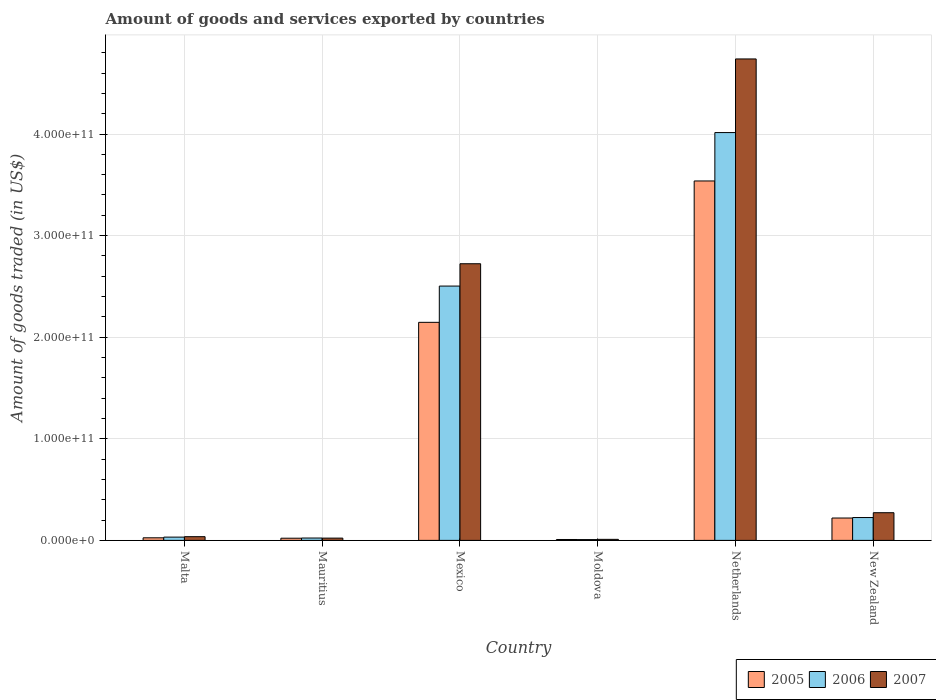Are the number of bars per tick equal to the number of legend labels?
Your response must be concise. Yes. How many bars are there on the 2nd tick from the left?
Your answer should be compact. 3. What is the label of the 2nd group of bars from the left?
Your answer should be compact. Mauritius. What is the total amount of goods and services exported in 2005 in Malta?
Provide a short and direct response. 2.54e+09. Across all countries, what is the maximum total amount of goods and services exported in 2005?
Offer a terse response. 3.54e+11. Across all countries, what is the minimum total amount of goods and services exported in 2005?
Ensure brevity in your answer.  8.86e+08. In which country was the total amount of goods and services exported in 2007 maximum?
Your response must be concise. Netherlands. In which country was the total amount of goods and services exported in 2005 minimum?
Keep it short and to the point. Moldova. What is the total total amount of goods and services exported in 2007 in the graph?
Give a very brief answer. 7.80e+11. What is the difference between the total amount of goods and services exported in 2007 in Mexico and that in Moldova?
Offer a terse response. 2.71e+11. What is the difference between the total amount of goods and services exported in 2007 in Malta and the total amount of goods and services exported in 2006 in New Zealand?
Offer a very short reply. -1.88e+1. What is the average total amount of goods and services exported in 2006 per country?
Keep it short and to the point. 1.13e+11. What is the difference between the total amount of goods and services exported of/in 2006 and total amount of goods and services exported of/in 2007 in Netherlands?
Make the answer very short. -7.25e+1. In how many countries, is the total amount of goods and services exported in 2007 greater than 160000000000 US$?
Provide a short and direct response. 2. What is the ratio of the total amount of goods and services exported in 2005 in Malta to that in Mauritius?
Offer a very short reply. 1.19. Is the total amount of goods and services exported in 2005 in Malta less than that in New Zealand?
Provide a succinct answer. Yes. Is the difference between the total amount of goods and services exported in 2006 in Netherlands and New Zealand greater than the difference between the total amount of goods and services exported in 2007 in Netherlands and New Zealand?
Keep it short and to the point. No. What is the difference between the highest and the second highest total amount of goods and services exported in 2007?
Your answer should be compact. 2.02e+11. What is the difference between the highest and the lowest total amount of goods and services exported in 2007?
Provide a short and direct response. 4.73e+11. In how many countries, is the total amount of goods and services exported in 2006 greater than the average total amount of goods and services exported in 2006 taken over all countries?
Provide a succinct answer. 2. What does the 3rd bar from the left in Netherlands represents?
Give a very brief answer. 2007. What does the 1st bar from the right in Netherlands represents?
Provide a short and direct response. 2007. How many bars are there?
Give a very brief answer. 18. What is the difference between two consecutive major ticks on the Y-axis?
Your answer should be very brief. 1.00e+11. Does the graph contain grids?
Provide a short and direct response. Yes. How many legend labels are there?
Provide a short and direct response. 3. How are the legend labels stacked?
Your response must be concise. Horizontal. What is the title of the graph?
Your answer should be very brief. Amount of goods and services exported by countries. Does "2014" appear as one of the legend labels in the graph?
Keep it short and to the point. No. What is the label or title of the Y-axis?
Provide a succinct answer. Amount of goods traded (in US$). What is the Amount of goods traded (in US$) of 2005 in Malta?
Ensure brevity in your answer.  2.54e+09. What is the Amount of goods traded (in US$) of 2006 in Malta?
Make the answer very short. 3.23e+09. What is the Amount of goods traded (in US$) in 2007 in Malta?
Your answer should be very brief. 3.66e+09. What is the Amount of goods traded (in US$) in 2005 in Mauritius?
Give a very brief answer. 2.14e+09. What is the Amount of goods traded (in US$) of 2006 in Mauritius?
Ensure brevity in your answer.  2.33e+09. What is the Amount of goods traded (in US$) in 2007 in Mauritius?
Ensure brevity in your answer.  2.24e+09. What is the Amount of goods traded (in US$) of 2005 in Mexico?
Your answer should be compact. 2.15e+11. What is the Amount of goods traded (in US$) in 2006 in Mexico?
Offer a very short reply. 2.50e+11. What is the Amount of goods traded (in US$) in 2007 in Mexico?
Offer a terse response. 2.72e+11. What is the Amount of goods traded (in US$) in 2005 in Moldova?
Give a very brief answer. 8.86e+08. What is the Amount of goods traded (in US$) of 2006 in Moldova?
Make the answer very short. 7.87e+08. What is the Amount of goods traded (in US$) of 2007 in Moldova?
Your answer should be very brief. 1.03e+09. What is the Amount of goods traded (in US$) of 2005 in Netherlands?
Ensure brevity in your answer.  3.54e+11. What is the Amount of goods traded (in US$) of 2006 in Netherlands?
Offer a very short reply. 4.01e+11. What is the Amount of goods traded (in US$) in 2007 in Netherlands?
Your answer should be compact. 4.74e+11. What is the Amount of goods traded (in US$) in 2005 in New Zealand?
Your response must be concise. 2.20e+1. What is the Amount of goods traded (in US$) in 2006 in New Zealand?
Provide a succinct answer. 2.25e+1. What is the Amount of goods traded (in US$) in 2007 in New Zealand?
Provide a short and direct response. 2.72e+1. Across all countries, what is the maximum Amount of goods traded (in US$) of 2005?
Ensure brevity in your answer.  3.54e+11. Across all countries, what is the maximum Amount of goods traded (in US$) of 2006?
Offer a very short reply. 4.01e+11. Across all countries, what is the maximum Amount of goods traded (in US$) of 2007?
Your answer should be very brief. 4.74e+11. Across all countries, what is the minimum Amount of goods traded (in US$) in 2005?
Your answer should be very brief. 8.86e+08. Across all countries, what is the minimum Amount of goods traded (in US$) of 2006?
Offer a very short reply. 7.87e+08. Across all countries, what is the minimum Amount of goods traded (in US$) of 2007?
Ensure brevity in your answer.  1.03e+09. What is the total Amount of goods traded (in US$) in 2005 in the graph?
Your response must be concise. 5.96e+11. What is the total Amount of goods traded (in US$) in 2006 in the graph?
Your answer should be very brief. 6.81e+11. What is the total Amount of goods traded (in US$) in 2007 in the graph?
Ensure brevity in your answer.  7.80e+11. What is the difference between the Amount of goods traded (in US$) in 2005 in Malta and that in Mauritius?
Provide a short and direct response. 4.06e+08. What is the difference between the Amount of goods traded (in US$) in 2006 in Malta and that in Mauritius?
Keep it short and to the point. 8.99e+08. What is the difference between the Amount of goods traded (in US$) in 2007 in Malta and that in Mauritius?
Give a very brief answer. 1.42e+09. What is the difference between the Amount of goods traded (in US$) in 2005 in Malta and that in Mexico?
Give a very brief answer. -2.12e+11. What is the difference between the Amount of goods traded (in US$) of 2006 in Malta and that in Mexico?
Your response must be concise. -2.47e+11. What is the difference between the Amount of goods traded (in US$) of 2007 in Malta and that in Mexico?
Make the answer very short. -2.69e+11. What is the difference between the Amount of goods traded (in US$) of 2005 in Malta and that in Moldova?
Offer a very short reply. 1.66e+09. What is the difference between the Amount of goods traded (in US$) in 2006 in Malta and that in Moldova?
Your answer should be very brief. 2.44e+09. What is the difference between the Amount of goods traded (in US$) of 2007 in Malta and that in Moldova?
Ensure brevity in your answer.  2.63e+09. What is the difference between the Amount of goods traded (in US$) in 2005 in Malta and that in Netherlands?
Your answer should be compact. -3.51e+11. What is the difference between the Amount of goods traded (in US$) in 2006 in Malta and that in Netherlands?
Your response must be concise. -3.98e+11. What is the difference between the Amount of goods traded (in US$) of 2007 in Malta and that in Netherlands?
Offer a terse response. -4.70e+11. What is the difference between the Amount of goods traded (in US$) in 2005 in Malta and that in New Zealand?
Your answer should be compact. -1.95e+1. What is the difference between the Amount of goods traded (in US$) in 2006 in Malta and that in New Zealand?
Give a very brief answer. -1.93e+1. What is the difference between the Amount of goods traded (in US$) in 2007 in Malta and that in New Zealand?
Give a very brief answer. -2.36e+1. What is the difference between the Amount of goods traded (in US$) in 2005 in Mauritius and that in Mexico?
Make the answer very short. -2.12e+11. What is the difference between the Amount of goods traded (in US$) in 2006 in Mauritius and that in Mexico?
Your answer should be compact. -2.48e+11. What is the difference between the Amount of goods traded (in US$) in 2007 in Mauritius and that in Mexico?
Your answer should be very brief. -2.70e+11. What is the difference between the Amount of goods traded (in US$) in 2005 in Mauritius and that in Moldova?
Provide a succinct answer. 1.25e+09. What is the difference between the Amount of goods traded (in US$) in 2006 in Mauritius and that in Moldova?
Ensure brevity in your answer.  1.54e+09. What is the difference between the Amount of goods traded (in US$) of 2007 in Mauritius and that in Moldova?
Give a very brief answer. 1.21e+09. What is the difference between the Amount of goods traded (in US$) in 2005 in Mauritius and that in Netherlands?
Make the answer very short. -3.52e+11. What is the difference between the Amount of goods traded (in US$) in 2006 in Mauritius and that in Netherlands?
Keep it short and to the point. -3.99e+11. What is the difference between the Amount of goods traded (in US$) of 2007 in Mauritius and that in Netherlands?
Offer a very short reply. -4.72e+11. What is the difference between the Amount of goods traded (in US$) of 2005 in Mauritius and that in New Zealand?
Provide a short and direct response. -1.99e+1. What is the difference between the Amount of goods traded (in US$) of 2006 in Mauritius and that in New Zealand?
Provide a short and direct response. -2.02e+1. What is the difference between the Amount of goods traded (in US$) of 2007 in Mauritius and that in New Zealand?
Your response must be concise. -2.50e+1. What is the difference between the Amount of goods traded (in US$) in 2005 in Mexico and that in Moldova?
Provide a succinct answer. 2.14e+11. What is the difference between the Amount of goods traded (in US$) in 2006 in Mexico and that in Moldova?
Your answer should be compact. 2.50e+11. What is the difference between the Amount of goods traded (in US$) in 2007 in Mexico and that in Moldova?
Give a very brief answer. 2.71e+11. What is the difference between the Amount of goods traded (in US$) of 2005 in Mexico and that in Netherlands?
Offer a very short reply. -1.39e+11. What is the difference between the Amount of goods traded (in US$) in 2006 in Mexico and that in Netherlands?
Give a very brief answer. -1.51e+11. What is the difference between the Amount of goods traded (in US$) of 2007 in Mexico and that in Netherlands?
Provide a short and direct response. -2.02e+11. What is the difference between the Amount of goods traded (in US$) of 2005 in Mexico and that in New Zealand?
Your answer should be very brief. 1.93e+11. What is the difference between the Amount of goods traded (in US$) in 2006 in Mexico and that in New Zealand?
Provide a succinct answer. 2.28e+11. What is the difference between the Amount of goods traded (in US$) in 2007 in Mexico and that in New Zealand?
Offer a very short reply. 2.45e+11. What is the difference between the Amount of goods traded (in US$) in 2005 in Moldova and that in Netherlands?
Keep it short and to the point. -3.53e+11. What is the difference between the Amount of goods traded (in US$) in 2006 in Moldova and that in Netherlands?
Your answer should be compact. -4.01e+11. What is the difference between the Amount of goods traded (in US$) in 2007 in Moldova and that in Netherlands?
Your response must be concise. -4.73e+11. What is the difference between the Amount of goods traded (in US$) of 2005 in Moldova and that in New Zealand?
Ensure brevity in your answer.  -2.11e+1. What is the difference between the Amount of goods traded (in US$) of 2006 in Moldova and that in New Zealand?
Ensure brevity in your answer.  -2.17e+1. What is the difference between the Amount of goods traded (in US$) in 2007 in Moldova and that in New Zealand?
Offer a terse response. -2.62e+1. What is the difference between the Amount of goods traded (in US$) in 2005 in Netherlands and that in New Zealand?
Keep it short and to the point. 3.32e+11. What is the difference between the Amount of goods traded (in US$) in 2006 in Netherlands and that in New Zealand?
Your response must be concise. 3.79e+11. What is the difference between the Amount of goods traded (in US$) of 2007 in Netherlands and that in New Zealand?
Offer a terse response. 4.47e+11. What is the difference between the Amount of goods traded (in US$) in 2005 in Malta and the Amount of goods traded (in US$) in 2006 in Mauritius?
Your answer should be very brief. 2.16e+08. What is the difference between the Amount of goods traded (in US$) of 2005 in Malta and the Amount of goods traded (in US$) of 2007 in Mauritius?
Your response must be concise. 3.07e+08. What is the difference between the Amount of goods traded (in US$) of 2006 in Malta and the Amount of goods traded (in US$) of 2007 in Mauritius?
Offer a terse response. 9.90e+08. What is the difference between the Amount of goods traded (in US$) in 2005 in Malta and the Amount of goods traded (in US$) in 2006 in Mexico?
Ensure brevity in your answer.  -2.48e+11. What is the difference between the Amount of goods traded (in US$) in 2005 in Malta and the Amount of goods traded (in US$) in 2007 in Mexico?
Make the answer very short. -2.70e+11. What is the difference between the Amount of goods traded (in US$) in 2006 in Malta and the Amount of goods traded (in US$) in 2007 in Mexico?
Offer a very short reply. -2.69e+11. What is the difference between the Amount of goods traded (in US$) in 2005 in Malta and the Amount of goods traded (in US$) in 2006 in Moldova?
Offer a very short reply. 1.76e+09. What is the difference between the Amount of goods traded (in US$) in 2005 in Malta and the Amount of goods traded (in US$) in 2007 in Moldova?
Ensure brevity in your answer.  1.52e+09. What is the difference between the Amount of goods traded (in US$) in 2006 in Malta and the Amount of goods traded (in US$) in 2007 in Moldova?
Your answer should be very brief. 2.20e+09. What is the difference between the Amount of goods traded (in US$) in 2005 in Malta and the Amount of goods traded (in US$) in 2006 in Netherlands?
Your response must be concise. -3.99e+11. What is the difference between the Amount of goods traded (in US$) in 2005 in Malta and the Amount of goods traded (in US$) in 2007 in Netherlands?
Keep it short and to the point. -4.71e+11. What is the difference between the Amount of goods traded (in US$) in 2006 in Malta and the Amount of goods traded (in US$) in 2007 in Netherlands?
Provide a short and direct response. -4.71e+11. What is the difference between the Amount of goods traded (in US$) of 2005 in Malta and the Amount of goods traded (in US$) of 2006 in New Zealand?
Keep it short and to the point. -2.00e+1. What is the difference between the Amount of goods traded (in US$) of 2005 in Malta and the Amount of goods traded (in US$) of 2007 in New Zealand?
Make the answer very short. -2.47e+1. What is the difference between the Amount of goods traded (in US$) of 2006 in Malta and the Amount of goods traded (in US$) of 2007 in New Zealand?
Ensure brevity in your answer.  -2.40e+1. What is the difference between the Amount of goods traded (in US$) in 2005 in Mauritius and the Amount of goods traded (in US$) in 2006 in Mexico?
Make the answer very short. -2.48e+11. What is the difference between the Amount of goods traded (in US$) in 2005 in Mauritius and the Amount of goods traded (in US$) in 2007 in Mexico?
Offer a very short reply. -2.70e+11. What is the difference between the Amount of goods traded (in US$) of 2006 in Mauritius and the Amount of goods traded (in US$) of 2007 in Mexico?
Keep it short and to the point. -2.70e+11. What is the difference between the Amount of goods traded (in US$) of 2005 in Mauritius and the Amount of goods traded (in US$) of 2006 in Moldova?
Offer a terse response. 1.35e+09. What is the difference between the Amount of goods traded (in US$) of 2005 in Mauritius and the Amount of goods traded (in US$) of 2007 in Moldova?
Your answer should be compact. 1.11e+09. What is the difference between the Amount of goods traded (in US$) in 2006 in Mauritius and the Amount of goods traded (in US$) in 2007 in Moldova?
Offer a very short reply. 1.30e+09. What is the difference between the Amount of goods traded (in US$) of 2005 in Mauritius and the Amount of goods traded (in US$) of 2006 in Netherlands?
Your answer should be very brief. -3.99e+11. What is the difference between the Amount of goods traded (in US$) in 2005 in Mauritius and the Amount of goods traded (in US$) in 2007 in Netherlands?
Make the answer very short. -4.72e+11. What is the difference between the Amount of goods traded (in US$) in 2006 in Mauritius and the Amount of goods traded (in US$) in 2007 in Netherlands?
Make the answer very short. -4.72e+11. What is the difference between the Amount of goods traded (in US$) in 2005 in Mauritius and the Amount of goods traded (in US$) in 2006 in New Zealand?
Your response must be concise. -2.04e+1. What is the difference between the Amount of goods traded (in US$) in 2005 in Mauritius and the Amount of goods traded (in US$) in 2007 in New Zealand?
Make the answer very short. -2.51e+1. What is the difference between the Amount of goods traded (in US$) in 2006 in Mauritius and the Amount of goods traded (in US$) in 2007 in New Zealand?
Offer a terse response. -2.49e+1. What is the difference between the Amount of goods traded (in US$) of 2005 in Mexico and the Amount of goods traded (in US$) of 2006 in Moldova?
Your answer should be very brief. 2.14e+11. What is the difference between the Amount of goods traded (in US$) of 2005 in Mexico and the Amount of goods traded (in US$) of 2007 in Moldova?
Your answer should be compact. 2.14e+11. What is the difference between the Amount of goods traded (in US$) in 2006 in Mexico and the Amount of goods traded (in US$) in 2007 in Moldova?
Offer a terse response. 2.49e+11. What is the difference between the Amount of goods traded (in US$) of 2005 in Mexico and the Amount of goods traded (in US$) of 2006 in Netherlands?
Provide a short and direct response. -1.87e+11. What is the difference between the Amount of goods traded (in US$) in 2005 in Mexico and the Amount of goods traded (in US$) in 2007 in Netherlands?
Provide a succinct answer. -2.59e+11. What is the difference between the Amount of goods traded (in US$) of 2006 in Mexico and the Amount of goods traded (in US$) of 2007 in Netherlands?
Your answer should be compact. -2.24e+11. What is the difference between the Amount of goods traded (in US$) in 2005 in Mexico and the Amount of goods traded (in US$) in 2006 in New Zealand?
Offer a terse response. 1.92e+11. What is the difference between the Amount of goods traded (in US$) in 2005 in Mexico and the Amount of goods traded (in US$) in 2007 in New Zealand?
Ensure brevity in your answer.  1.87e+11. What is the difference between the Amount of goods traded (in US$) in 2006 in Mexico and the Amount of goods traded (in US$) in 2007 in New Zealand?
Your answer should be very brief. 2.23e+11. What is the difference between the Amount of goods traded (in US$) in 2005 in Moldova and the Amount of goods traded (in US$) in 2006 in Netherlands?
Make the answer very short. -4.01e+11. What is the difference between the Amount of goods traded (in US$) in 2005 in Moldova and the Amount of goods traded (in US$) in 2007 in Netherlands?
Keep it short and to the point. -4.73e+11. What is the difference between the Amount of goods traded (in US$) in 2006 in Moldova and the Amount of goods traded (in US$) in 2007 in Netherlands?
Offer a very short reply. -4.73e+11. What is the difference between the Amount of goods traded (in US$) in 2005 in Moldova and the Amount of goods traded (in US$) in 2006 in New Zealand?
Your response must be concise. -2.16e+1. What is the difference between the Amount of goods traded (in US$) in 2005 in Moldova and the Amount of goods traded (in US$) in 2007 in New Zealand?
Give a very brief answer. -2.64e+1. What is the difference between the Amount of goods traded (in US$) of 2006 in Moldova and the Amount of goods traded (in US$) of 2007 in New Zealand?
Give a very brief answer. -2.65e+1. What is the difference between the Amount of goods traded (in US$) of 2005 in Netherlands and the Amount of goods traded (in US$) of 2006 in New Zealand?
Offer a terse response. 3.31e+11. What is the difference between the Amount of goods traded (in US$) of 2005 in Netherlands and the Amount of goods traded (in US$) of 2007 in New Zealand?
Your answer should be compact. 3.27e+11. What is the difference between the Amount of goods traded (in US$) of 2006 in Netherlands and the Amount of goods traded (in US$) of 2007 in New Zealand?
Your answer should be very brief. 3.74e+11. What is the average Amount of goods traded (in US$) of 2005 per country?
Your answer should be very brief. 9.93e+1. What is the average Amount of goods traded (in US$) in 2006 per country?
Provide a succinct answer. 1.13e+11. What is the average Amount of goods traded (in US$) in 2007 per country?
Give a very brief answer. 1.30e+11. What is the difference between the Amount of goods traded (in US$) in 2005 and Amount of goods traded (in US$) in 2006 in Malta?
Your answer should be very brief. -6.83e+08. What is the difference between the Amount of goods traded (in US$) in 2005 and Amount of goods traded (in US$) in 2007 in Malta?
Provide a succinct answer. -1.11e+09. What is the difference between the Amount of goods traded (in US$) of 2006 and Amount of goods traded (in US$) of 2007 in Malta?
Make the answer very short. -4.30e+08. What is the difference between the Amount of goods traded (in US$) of 2005 and Amount of goods traded (in US$) of 2006 in Mauritius?
Provide a short and direct response. -1.90e+08. What is the difference between the Amount of goods traded (in US$) of 2005 and Amount of goods traded (in US$) of 2007 in Mauritius?
Offer a terse response. -9.95e+07. What is the difference between the Amount of goods traded (in US$) in 2006 and Amount of goods traded (in US$) in 2007 in Mauritius?
Your answer should be compact. 9.09e+07. What is the difference between the Amount of goods traded (in US$) in 2005 and Amount of goods traded (in US$) in 2006 in Mexico?
Provide a short and direct response. -3.57e+1. What is the difference between the Amount of goods traded (in US$) of 2005 and Amount of goods traded (in US$) of 2007 in Mexico?
Provide a succinct answer. -5.77e+1. What is the difference between the Amount of goods traded (in US$) of 2006 and Amount of goods traded (in US$) of 2007 in Mexico?
Offer a very short reply. -2.20e+1. What is the difference between the Amount of goods traded (in US$) in 2005 and Amount of goods traded (in US$) in 2006 in Moldova?
Offer a very short reply. 9.92e+07. What is the difference between the Amount of goods traded (in US$) in 2005 and Amount of goods traded (in US$) in 2007 in Moldova?
Make the answer very short. -1.40e+08. What is the difference between the Amount of goods traded (in US$) of 2006 and Amount of goods traded (in US$) of 2007 in Moldova?
Make the answer very short. -2.39e+08. What is the difference between the Amount of goods traded (in US$) of 2005 and Amount of goods traded (in US$) of 2006 in Netherlands?
Offer a very short reply. -4.76e+1. What is the difference between the Amount of goods traded (in US$) in 2005 and Amount of goods traded (in US$) in 2007 in Netherlands?
Keep it short and to the point. -1.20e+11. What is the difference between the Amount of goods traded (in US$) in 2006 and Amount of goods traded (in US$) in 2007 in Netherlands?
Ensure brevity in your answer.  -7.25e+1. What is the difference between the Amount of goods traded (in US$) in 2005 and Amount of goods traded (in US$) in 2006 in New Zealand?
Your answer should be very brief. -4.80e+08. What is the difference between the Amount of goods traded (in US$) of 2005 and Amount of goods traded (in US$) of 2007 in New Zealand?
Offer a terse response. -5.23e+09. What is the difference between the Amount of goods traded (in US$) of 2006 and Amount of goods traded (in US$) of 2007 in New Zealand?
Provide a succinct answer. -4.75e+09. What is the ratio of the Amount of goods traded (in US$) in 2005 in Malta to that in Mauritius?
Provide a succinct answer. 1.19. What is the ratio of the Amount of goods traded (in US$) of 2006 in Malta to that in Mauritius?
Your answer should be compact. 1.39. What is the ratio of the Amount of goods traded (in US$) in 2007 in Malta to that in Mauritius?
Offer a very short reply. 1.63. What is the ratio of the Amount of goods traded (in US$) of 2005 in Malta to that in Mexico?
Offer a very short reply. 0.01. What is the ratio of the Amount of goods traded (in US$) of 2006 in Malta to that in Mexico?
Provide a succinct answer. 0.01. What is the ratio of the Amount of goods traded (in US$) of 2007 in Malta to that in Mexico?
Ensure brevity in your answer.  0.01. What is the ratio of the Amount of goods traded (in US$) in 2005 in Malta to that in Moldova?
Provide a short and direct response. 2.87. What is the ratio of the Amount of goods traded (in US$) in 2006 in Malta to that in Moldova?
Provide a succinct answer. 4.1. What is the ratio of the Amount of goods traded (in US$) of 2007 in Malta to that in Moldova?
Offer a terse response. 3.56. What is the ratio of the Amount of goods traded (in US$) in 2005 in Malta to that in Netherlands?
Your answer should be very brief. 0.01. What is the ratio of the Amount of goods traded (in US$) in 2006 in Malta to that in Netherlands?
Make the answer very short. 0.01. What is the ratio of the Amount of goods traded (in US$) in 2007 in Malta to that in Netherlands?
Offer a very short reply. 0.01. What is the ratio of the Amount of goods traded (in US$) in 2005 in Malta to that in New Zealand?
Ensure brevity in your answer.  0.12. What is the ratio of the Amount of goods traded (in US$) in 2006 in Malta to that in New Zealand?
Offer a very short reply. 0.14. What is the ratio of the Amount of goods traded (in US$) of 2007 in Malta to that in New Zealand?
Make the answer very short. 0.13. What is the ratio of the Amount of goods traded (in US$) of 2006 in Mauritius to that in Mexico?
Provide a short and direct response. 0.01. What is the ratio of the Amount of goods traded (in US$) in 2007 in Mauritius to that in Mexico?
Your response must be concise. 0.01. What is the ratio of the Amount of goods traded (in US$) of 2005 in Mauritius to that in Moldova?
Your answer should be compact. 2.41. What is the ratio of the Amount of goods traded (in US$) of 2006 in Mauritius to that in Moldova?
Keep it short and to the point. 2.96. What is the ratio of the Amount of goods traded (in US$) of 2007 in Mauritius to that in Moldova?
Give a very brief answer. 2.18. What is the ratio of the Amount of goods traded (in US$) of 2005 in Mauritius to that in Netherlands?
Provide a short and direct response. 0.01. What is the ratio of the Amount of goods traded (in US$) of 2006 in Mauritius to that in Netherlands?
Ensure brevity in your answer.  0.01. What is the ratio of the Amount of goods traded (in US$) of 2007 in Mauritius to that in Netherlands?
Your answer should be very brief. 0. What is the ratio of the Amount of goods traded (in US$) in 2005 in Mauritius to that in New Zealand?
Your answer should be compact. 0.1. What is the ratio of the Amount of goods traded (in US$) in 2006 in Mauritius to that in New Zealand?
Your answer should be compact. 0.1. What is the ratio of the Amount of goods traded (in US$) of 2007 in Mauritius to that in New Zealand?
Make the answer very short. 0.08. What is the ratio of the Amount of goods traded (in US$) of 2005 in Mexico to that in Moldova?
Your response must be concise. 242.22. What is the ratio of the Amount of goods traded (in US$) of 2006 in Mexico to that in Moldova?
Keep it short and to the point. 318.09. What is the ratio of the Amount of goods traded (in US$) of 2007 in Mexico to that in Moldova?
Provide a succinct answer. 265.39. What is the ratio of the Amount of goods traded (in US$) of 2005 in Mexico to that in Netherlands?
Your response must be concise. 0.61. What is the ratio of the Amount of goods traded (in US$) of 2006 in Mexico to that in Netherlands?
Provide a short and direct response. 0.62. What is the ratio of the Amount of goods traded (in US$) of 2007 in Mexico to that in Netherlands?
Your answer should be compact. 0.57. What is the ratio of the Amount of goods traded (in US$) of 2005 in Mexico to that in New Zealand?
Offer a terse response. 9.75. What is the ratio of the Amount of goods traded (in US$) in 2006 in Mexico to that in New Zealand?
Your response must be concise. 11.13. What is the ratio of the Amount of goods traded (in US$) in 2007 in Mexico to that in New Zealand?
Keep it short and to the point. 10. What is the ratio of the Amount of goods traded (in US$) in 2005 in Moldova to that in Netherlands?
Provide a short and direct response. 0. What is the ratio of the Amount of goods traded (in US$) in 2006 in Moldova to that in Netherlands?
Your answer should be very brief. 0. What is the ratio of the Amount of goods traded (in US$) in 2007 in Moldova to that in Netherlands?
Keep it short and to the point. 0. What is the ratio of the Amount of goods traded (in US$) in 2005 in Moldova to that in New Zealand?
Keep it short and to the point. 0.04. What is the ratio of the Amount of goods traded (in US$) of 2006 in Moldova to that in New Zealand?
Your answer should be very brief. 0.04. What is the ratio of the Amount of goods traded (in US$) of 2007 in Moldova to that in New Zealand?
Keep it short and to the point. 0.04. What is the ratio of the Amount of goods traded (in US$) in 2005 in Netherlands to that in New Zealand?
Offer a terse response. 16.07. What is the ratio of the Amount of goods traded (in US$) of 2006 in Netherlands to that in New Zealand?
Provide a short and direct response. 17.84. What is the ratio of the Amount of goods traded (in US$) in 2007 in Netherlands to that in New Zealand?
Offer a terse response. 17.4. What is the difference between the highest and the second highest Amount of goods traded (in US$) of 2005?
Your answer should be compact. 1.39e+11. What is the difference between the highest and the second highest Amount of goods traded (in US$) of 2006?
Make the answer very short. 1.51e+11. What is the difference between the highest and the second highest Amount of goods traded (in US$) in 2007?
Keep it short and to the point. 2.02e+11. What is the difference between the highest and the lowest Amount of goods traded (in US$) in 2005?
Keep it short and to the point. 3.53e+11. What is the difference between the highest and the lowest Amount of goods traded (in US$) of 2006?
Provide a short and direct response. 4.01e+11. What is the difference between the highest and the lowest Amount of goods traded (in US$) of 2007?
Provide a short and direct response. 4.73e+11. 